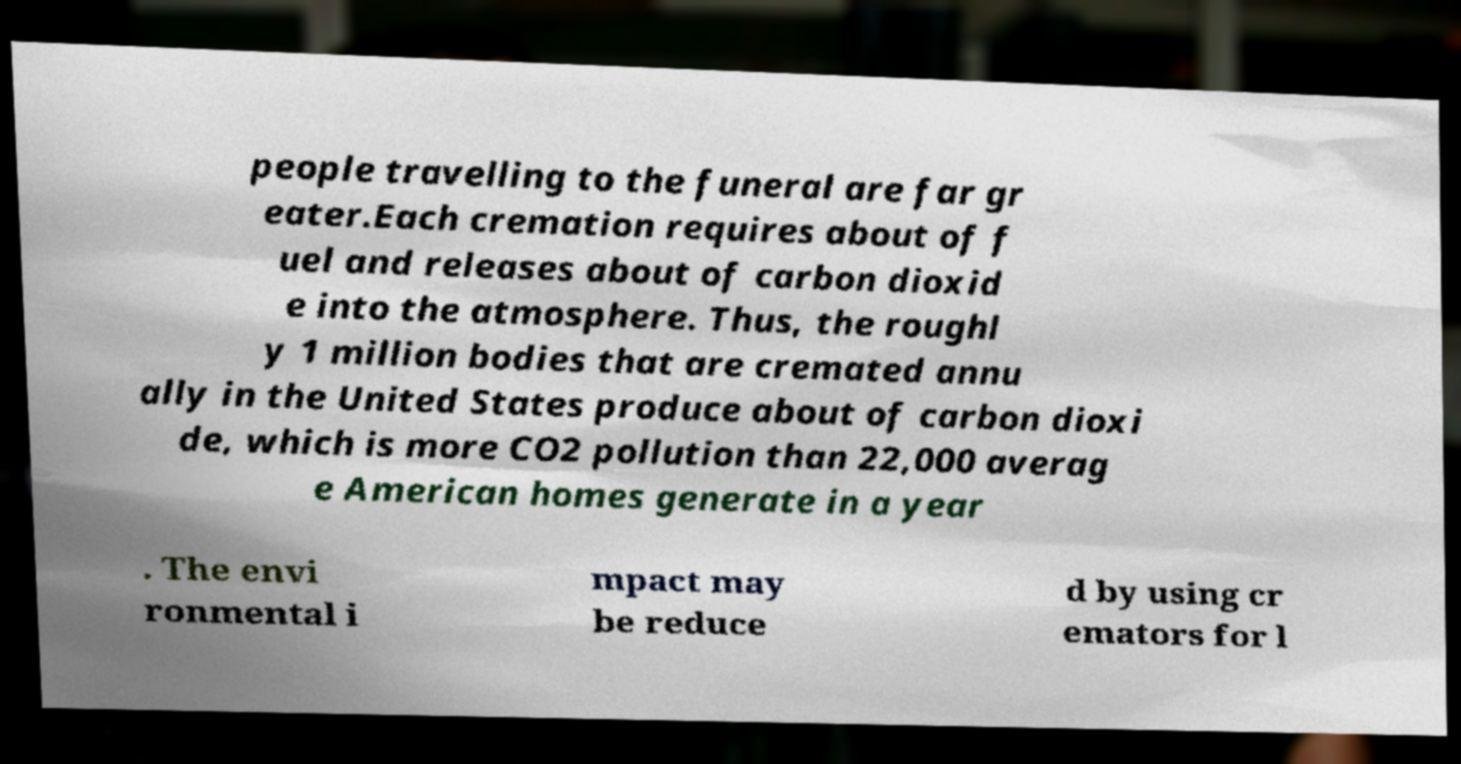Can you accurately transcribe the text from the provided image for me? people travelling to the funeral are far gr eater.Each cremation requires about of f uel and releases about of carbon dioxid e into the atmosphere. Thus, the roughl y 1 million bodies that are cremated annu ally in the United States produce about of carbon dioxi de, which is more CO2 pollution than 22,000 averag e American homes generate in a year . The envi ronmental i mpact may be reduce d by using cr emators for l 